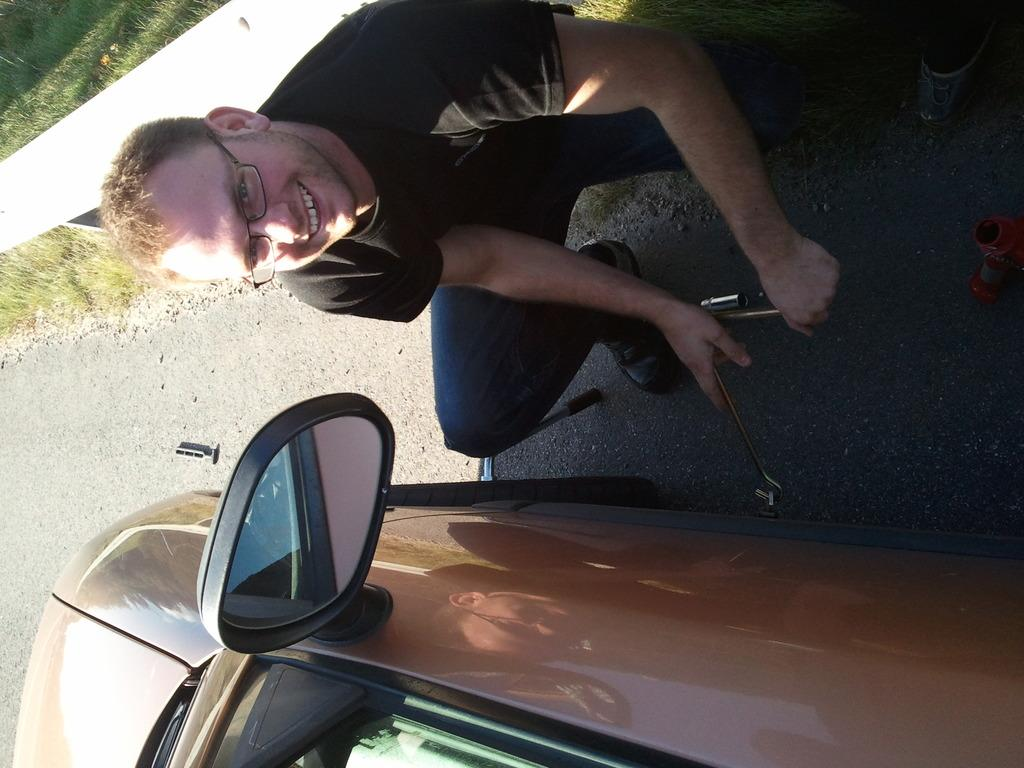Who is in the image? There is a man in the image. What position is the man in? The man is in the squat position. Where is the man located in relation to the car? The man is beside the car. What is the man holding in the image? The man is holding tools. What are the tools used for? The tools are for removing a tire. What needs to be done to the car in the image? The car has a tire that needs to be removed. What type of berry can be seen growing on the car in the image? There are no berries present on the car in the image. Can you describe the ducks that are walking around the man in the image? There are no ducks present in the image. 